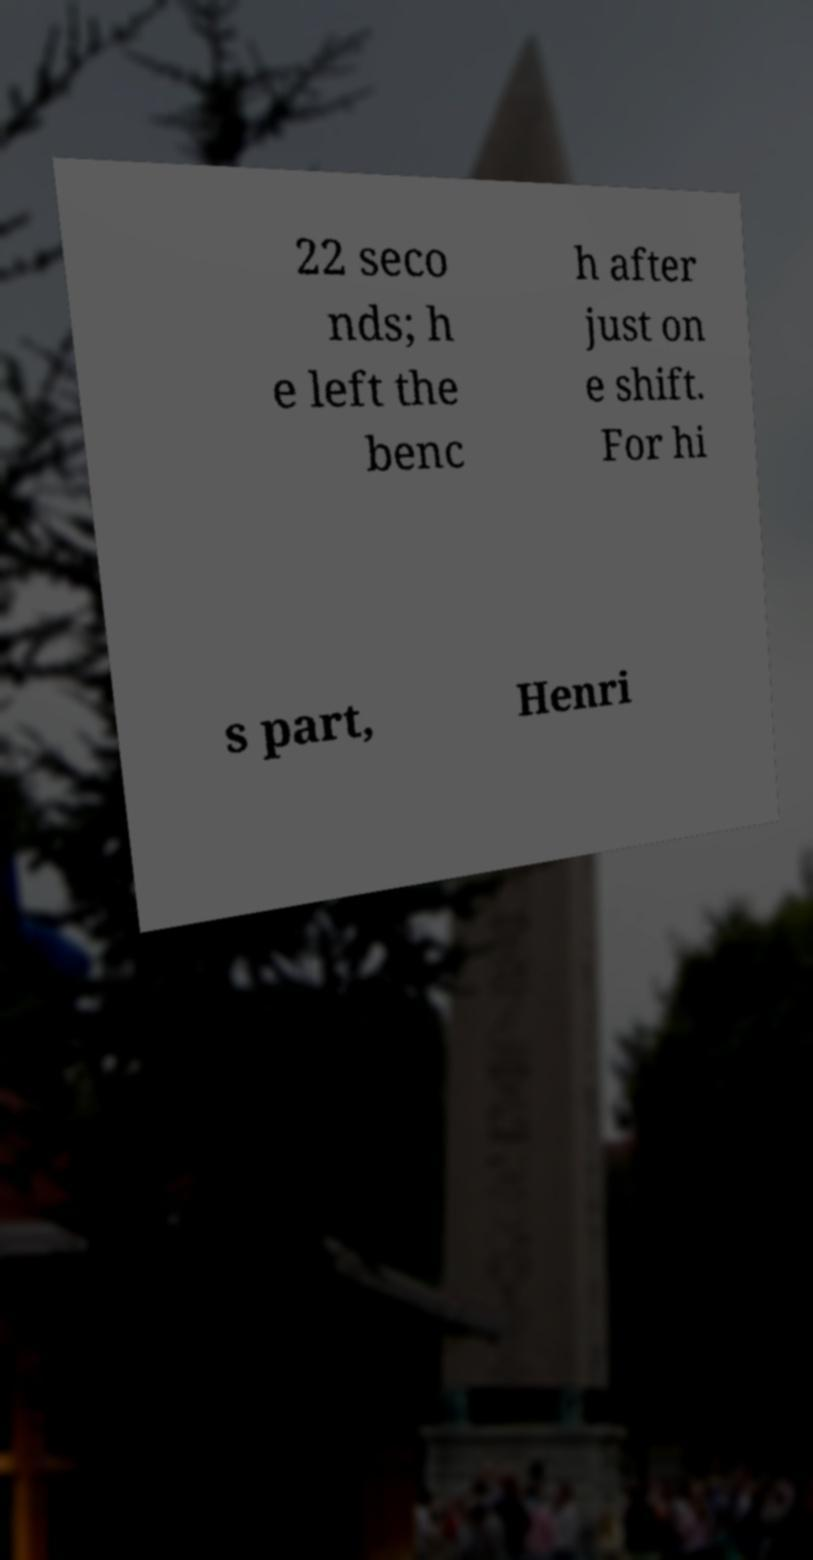What messages or text are displayed in this image? I need them in a readable, typed format. 22 seco nds; h e left the benc h after just on e shift. For hi s part, Henri 